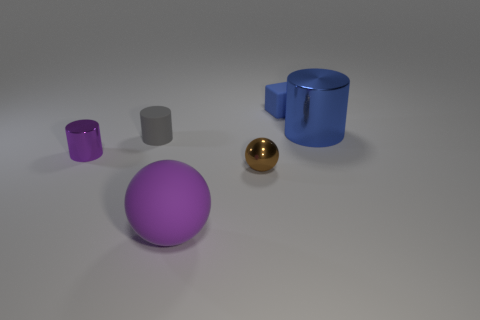Add 1 big red metallic cylinders. How many objects exist? 7 Subtract all blocks. How many objects are left? 5 Subtract 0 cyan balls. How many objects are left? 6 Subtract all brown objects. Subtract all big metal cylinders. How many objects are left? 4 Add 4 large purple objects. How many large purple objects are left? 5 Add 3 large cyan rubber cubes. How many large cyan rubber cubes exist? 3 